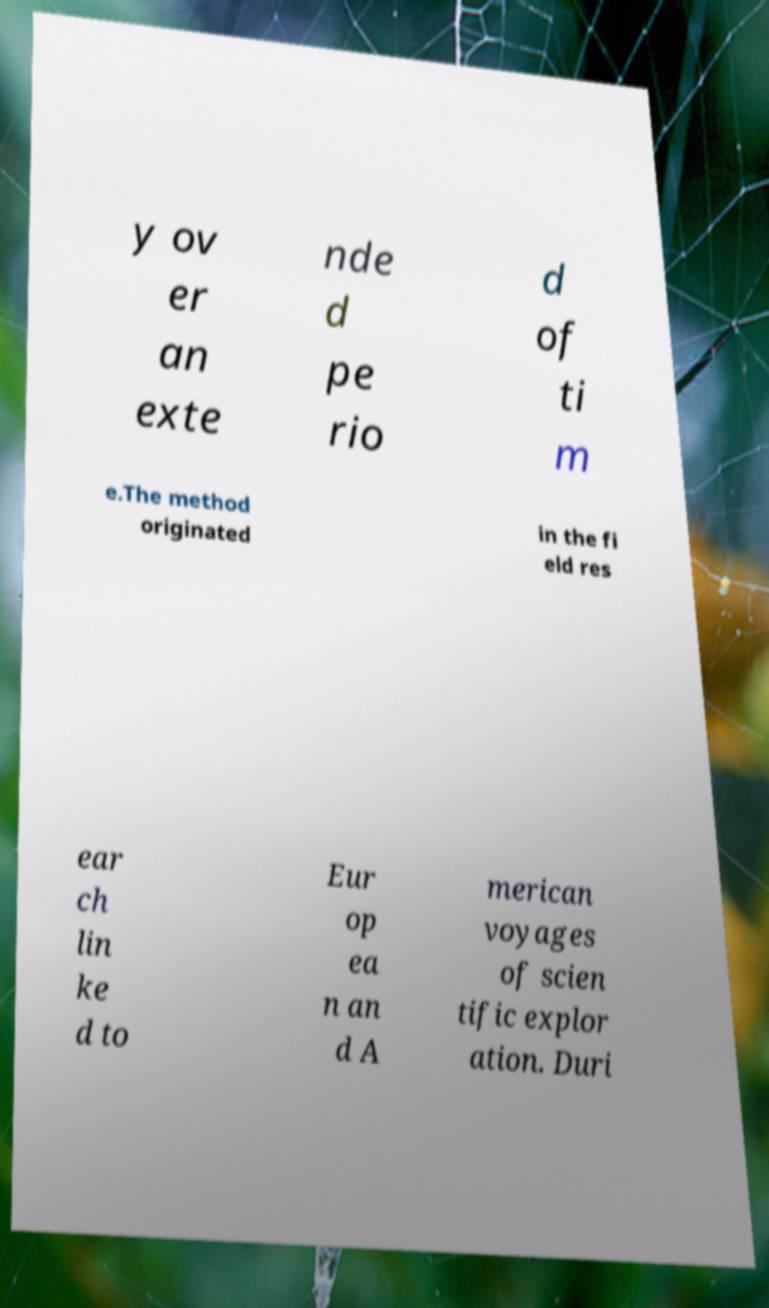There's text embedded in this image that I need extracted. Can you transcribe it verbatim? y ov er an exte nde d pe rio d of ti m e.The method originated in the fi eld res ear ch lin ke d to Eur op ea n an d A merican voyages of scien tific explor ation. Duri 